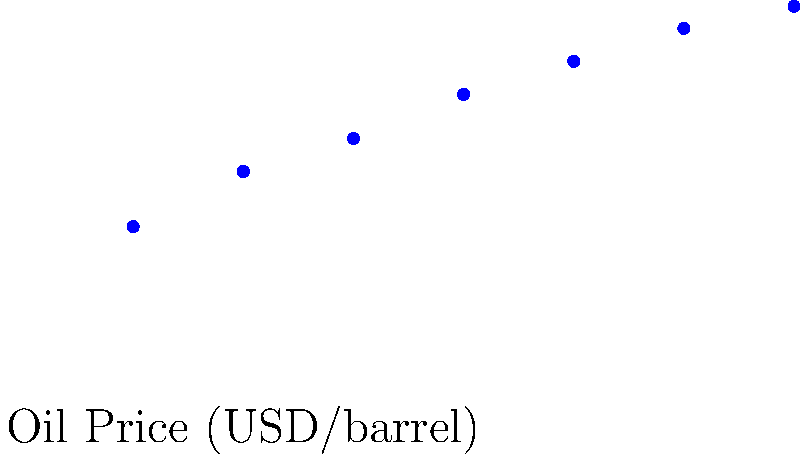Based on the scatter plot showing the relationship between oil prices and foreign investment inflows in Saudi Arabia, what can be inferred about the correlation between these two variables? How might this information be used to attract foreign investment? To answer this question, let's analyze the scatter plot step-by-step:

1. Observation of data points:
   The scatter plot shows a clear upward trend from left to right.

2. Correlation analysis:
   The positive slope of the data points indicates a positive correlation between oil prices and foreign investment inflows.

3. Strength of correlation:
   The data points are relatively close to the trend line, suggesting a strong correlation.

4. Interpretation:
   As oil prices increase, foreign investment in Saudi Arabia tends to increase as well.

5. Possible reasons:
   - Higher oil prices may indicate a stronger economy in Saudi Arabia, attracting more investors.
   - Increased oil revenues may lead to more government spending and economic opportunities.

6. Using this information to attract foreign investment:
   - Highlight the stability and growth potential of the Saudi economy, especially during periods of high oil prices.
   - Emphasize diversification efforts to reduce dependence on oil, which could attract investors even when oil prices are lower.
   - Develop policies that maintain a favorable investment climate regardless of oil price fluctuations.

7. Limitations:
   - Correlation does not imply causation; other factors may influence foreign investment.
   - The relationship may not be perfectly linear, and extreme oil price changes might have different effects.
Answer: Strong positive correlation between oil prices and foreign investment; use to promote economic stability and diversification efforts. 